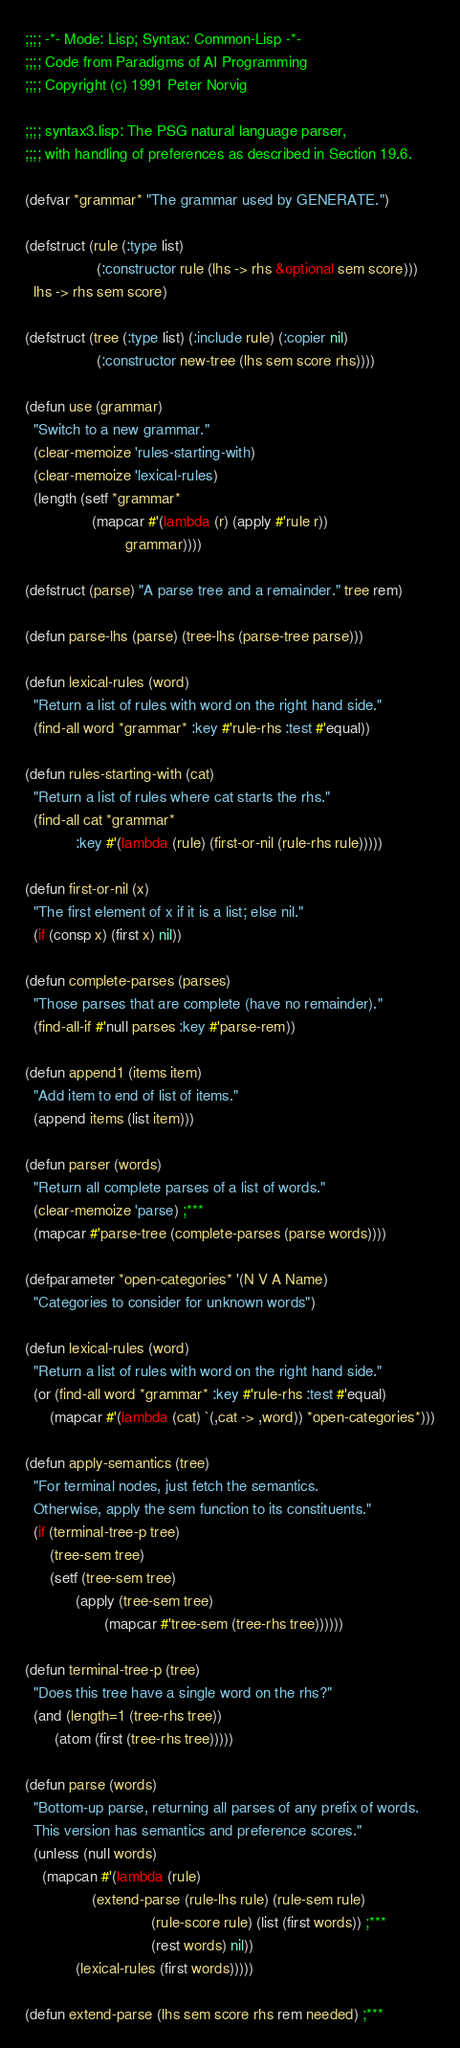Convert code to text. <code><loc_0><loc_0><loc_500><loc_500><_Lisp_>;;;; -*- Mode: Lisp; Syntax: Common-Lisp -*-
;;;; Code from Paradigms of AI Programming
;;;; Copyright (c) 1991 Peter Norvig

;;;; syntax3.lisp: The PSG natural language parser,
;;;; with handling of preferences as described in Section 19.6.

(defvar *grammar* "The grammar used by GENERATE.")

(defstruct (rule (:type list) 
                 (:constructor rule (lhs -> rhs &optional sem score)))
  lhs -> rhs sem score)

(defstruct (tree (:type list) (:include rule) (:copier nil)
                 (:constructor new-tree (lhs sem score rhs))))

(defun use (grammar)
  "Switch to a new grammar."
  (clear-memoize 'rules-starting-with)
  (clear-memoize 'lexical-rules)
  (length (setf *grammar* 
                (mapcar #'(lambda (r) (apply #'rule r))
                        grammar))))

(defstruct (parse) "A parse tree and a remainder." tree rem)

(defun parse-lhs (parse) (tree-lhs (parse-tree parse)))

(defun lexical-rules (word)
  "Return a list of rules with word on the right hand side."
  (find-all word *grammar* :key #'rule-rhs :test #'equal))

(defun rules-starting-with (cat)
  "Return a list of rules where cat starts the rhs."
  (find-all cat *grammar* 
            :key #'(lambda (rule) (first-or-nil (rule-rhs rule)))))

(defun first-or-nil (x)
  "The first element of x if it is a list; else nil."
  (if (consp x) (first x) nil))

(defun complete-parses (parses)
  "Those parses that are complete (have no remainder)."
  (find-all-if #'null parses :key #'parse-rem))

(defun append1 (items item)
  "Add item to end of list of items."
  (append items (list item)))

(defun parser (words)
  "Return all complete parses of a list of words."
  (clear-memoize 'parse) ;***
  (mapcar #'parse-tree (complete-parses (parse words))))

(defparameter *open-categories* '(N V A Name)
  "Categories to consider for unknown words")

(defun lexical-rules (word)
  "Return a list of rules with word on the right hand side."
  (or (find-all word *grammar* :key #'rule-rhs :test #'equal)
      (mapcar #'(lambda (cat) `(,cat -> ,word)) *open-categories*)))

(defun apply-semantics (tree)
  "For terminal nodes, just fetch the semantics.
  Otherwise, apply the sem function to its constituents."
  (if (terminal-tree-p tree)
      (tree-sem tree)
      (setf (tree-sem tree)
            (apply (tree-sem tree)
                   (mapcar #'tree-sem (tree-rhs tree))))))

(defun terminal-tree-p (tree)
  "Does this tree have a single word on the rhs?"
  (and (length=1 (tree-rhs tree))
       (atom (first (tree-rhs tree)))))

(defun parse (words)
  "Bottom-up parse, returning all parses of any prefix of words.
  This version has semantics and preference scores."
  (unless (null words)
    (mapcan #'(lambda (rule)
                (extend-parse (rule-lhs rule) (rule-sem rule)
                              (rule-score rule) (list (first words)) ;***
                              (rest words) nil))
            (lexical-rules (first words)))))

(defun extend-parse (lhs sem score rhs rem needed) ;***</code> 